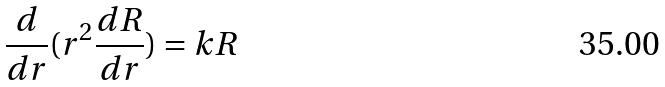<formula> <loc_0><loc_0><loc_500><loc_500>\frac { d } { d r } ( r ^ { 2 } \frac { d R } { d r } ) = k R</formula> 